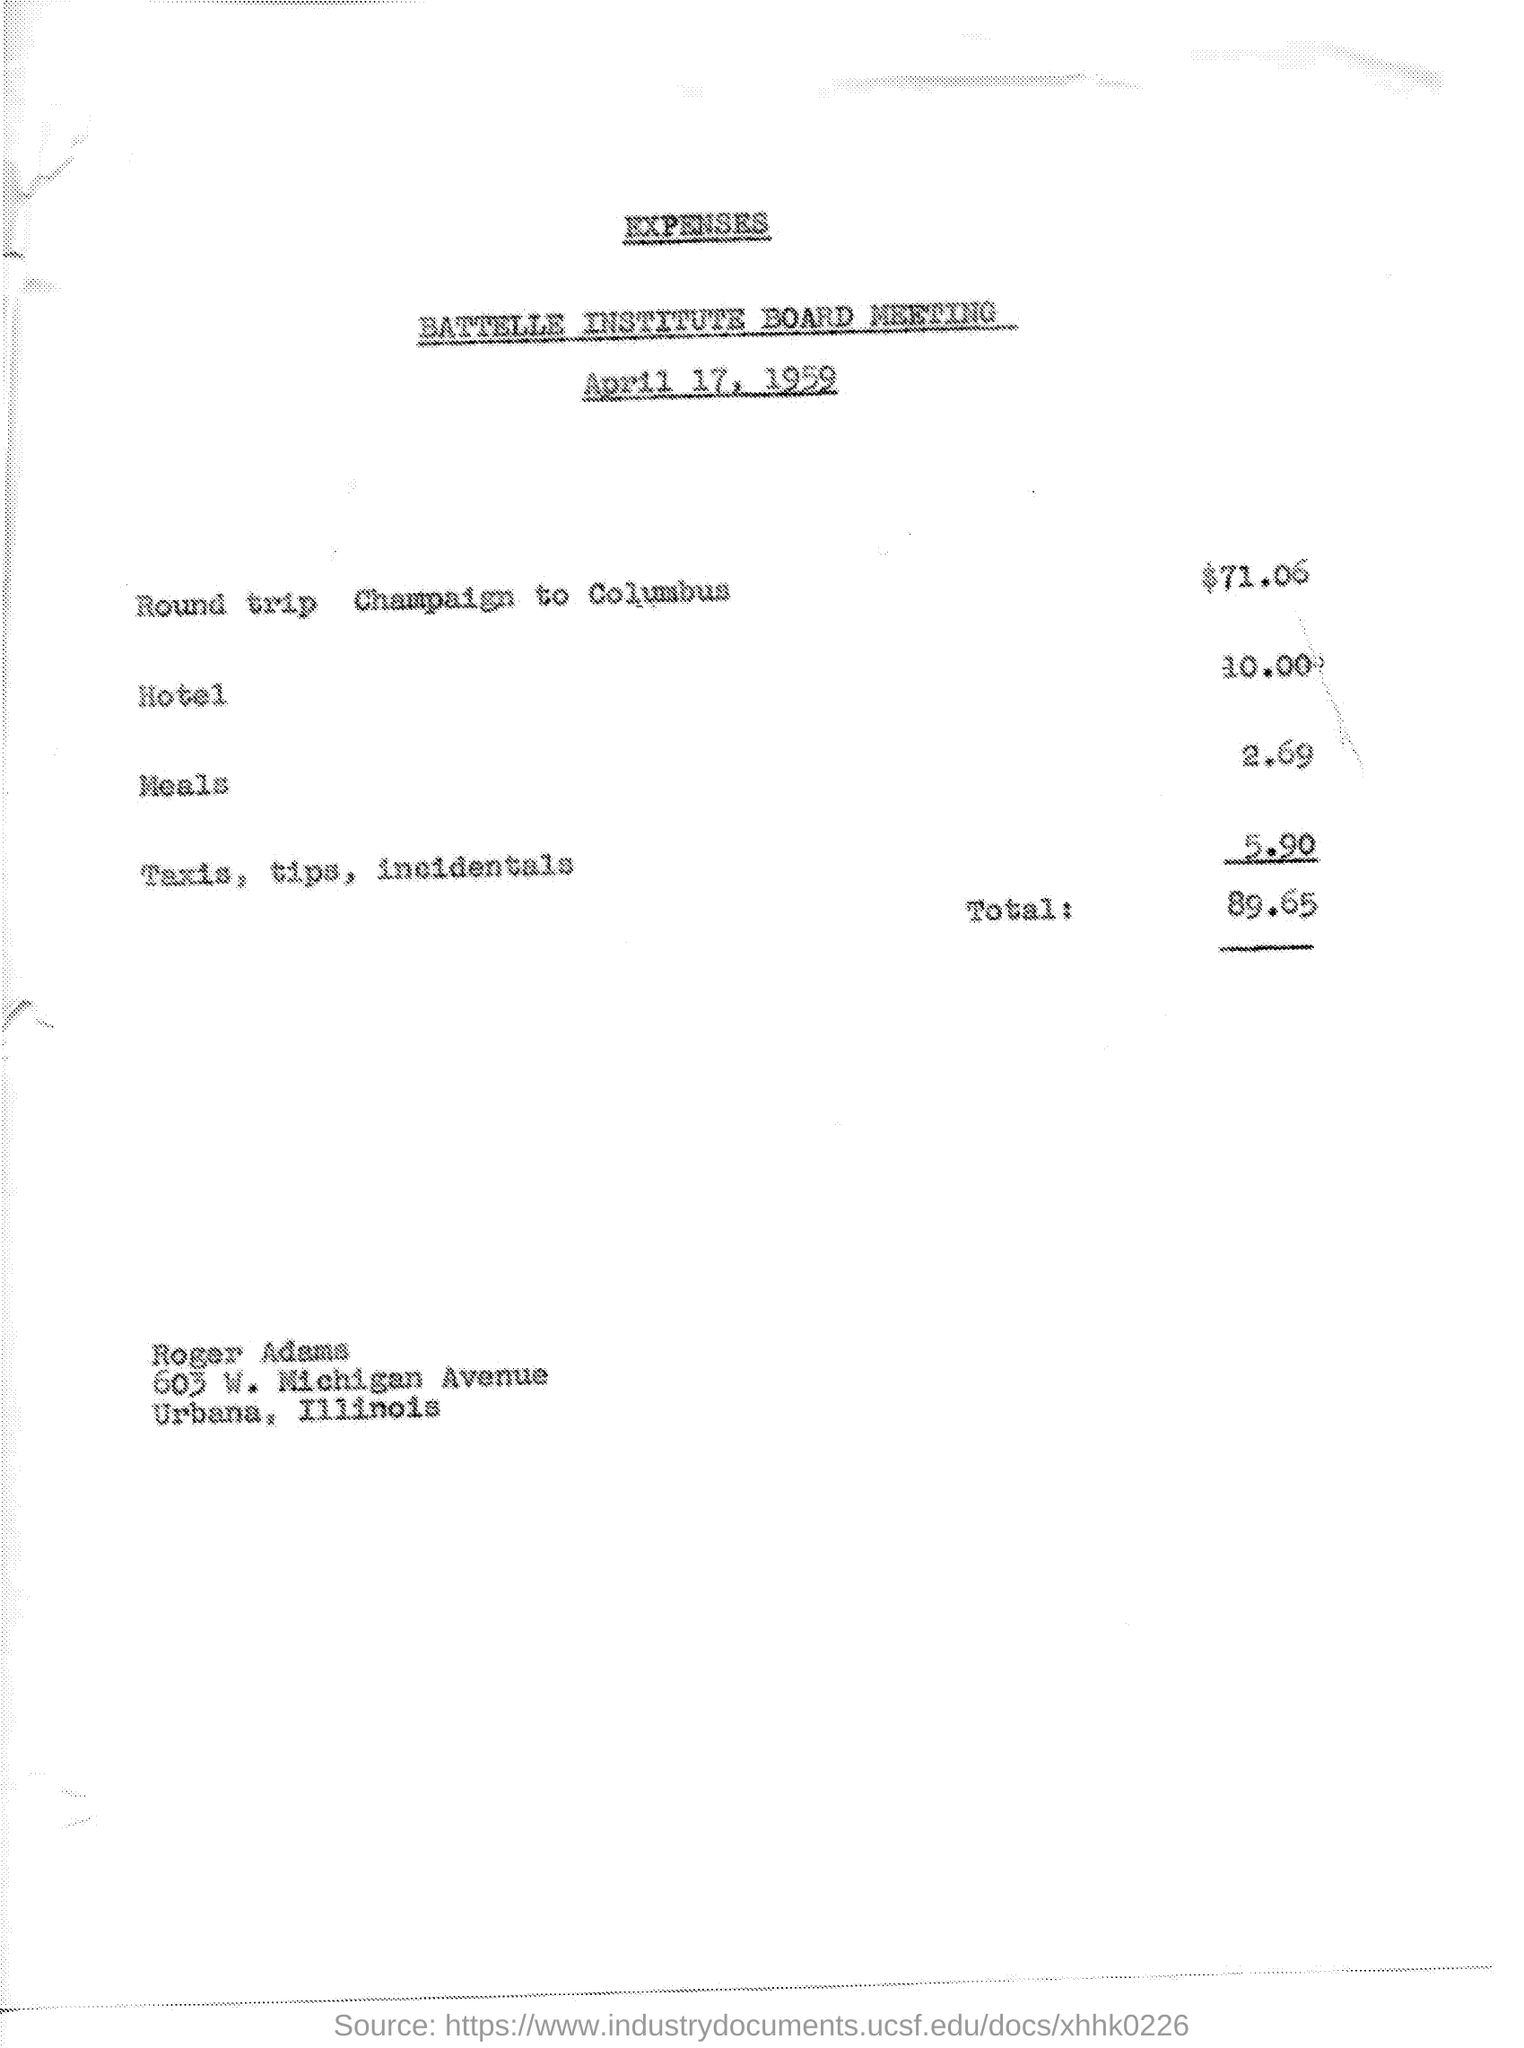What is the document title?
Your answer should be compact. Expenses. When is the document dated?
Provide a succinct answer. April 17, 1959. What is the expense of round trip Champaign to Columbus?
Make the answer very short. $71.06. What is the total amount in $?
Give a very brief answer. 89.65. 